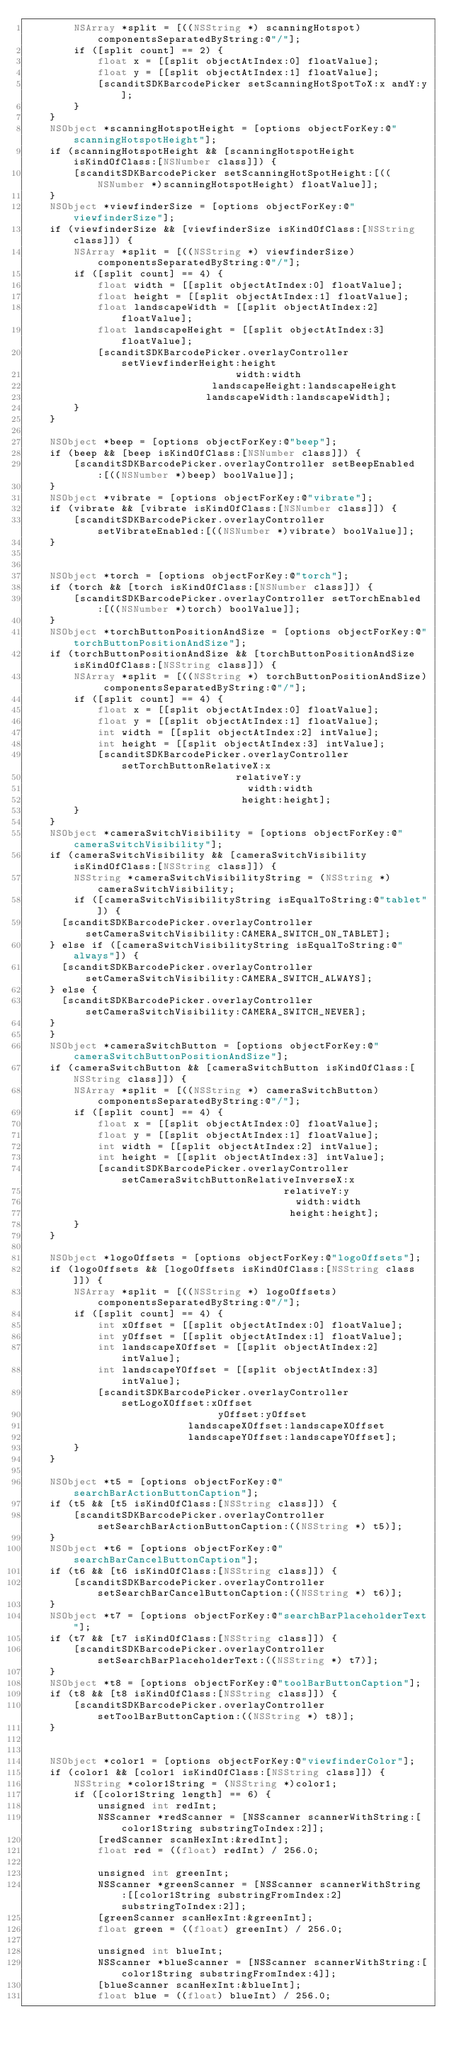Convert code to text. <code><loc_0><loc_0><loc_500><loc_500><_ObjectiveC_>        NSArray *split = [((NSString *) scanningHotspot) componentsSeparatedByString:@"/"];
        if ([split count] == 2) {
            float x = [[split objectAtIndex:0] floatValue];
            float y = [[split objectAtIndex:1] floatValue];
            [scanditSDKBarcodePicker setScanningHotSpotToX:x andY:y];
        }
    }
    NSObject *scanningHotspotHeight = [options objectForKey:@"scanningHotspotHeight"];
    if (scanningHotspotHeight && [scanningHotspotHeight isKindOfClass:[NSNumber class]]) {
        [scanditSDKBarcodePicker setScanningHotSpotHeight:[((NSNumber *)scanningHotspotHeight) floatValue]];
    }
    NSObject *viewfinderSize = [options objectForKey:@"viewfinderSize"];
    if (viewfinderSize && [viewfinderSize isKindOfClass:[NSString class]]) {
        NSArray *split = [((NSString *) viewfinderSize) componentsSeparatedByString:@"/"];
        if ([split count] == 4) {
            float width = [[split objectAtIndex:0] floatValue];
            float height = [[split objectAtIndex:1] floatValue];
            float landscapeWidth = [[split objectAtIndex:2] floatValue];
            float landscapeHeight = [[split objectAtIndex:3] floatValue];
            [scanditSDKBarcodePicker.overlayController setViewfinderHeight:height
																	 width:width
														   landscapeHeight:landscapeHeight
															landscapeWidth:landscapeWidth];
        }
    }
    
    NSObject *beep = [options objectForKey:@"beep"];
    if (beep && [beep isKindOfClass:[NSNumber class]]) {
        [scanditSDKBarcodePicker.overlayController setBeepEnabled:[((NSNumber *)beep) boolValue]];
    }
    NSObject *vibrate = [options objectForKey:@"vibrate"];
    if (vibrate && [vibrate isKindOfClass:[NSNumber class]]) {
        [scanditSDKBarcodePicker.overlayController setVibrateEnabled:[((NSNumber *)vibrate) boolValue]];
    }
	
    
    NSObject *torch = [options objectForKey:@"torch"];
    if (torch && [torch isKindOfClass:[NSNumber class]]) {
        [scanditSDKBarcodePicker.overlayController setTorchEnabled:[((NSNumber *)torch) boolValue]];
    }
    NSObject *torchButtonPositionAndSize = [options objectForKey:@"torchButtonPositionAndSize"];
    if (torchButtonPositionAndSize && [torchButtonPositionAndSize isKindOfClass:[NSString class]]) {
        NSArray *split = [((NSString *) torchButtonPositionAndSize) componentsSeparatedByString:@"/"];
        if ([split count] == 4) {
            float x = [[split objectAtIndex:0] floatValue];
            float y = [[split objectAtIndex:1] floatValue];
            int width = [[split objectAtIndex:2] intValue];
            int height = [[split objectAtIndex:3] intValue];
            [scanditSDKBarcodePicker.overlayController setTorchButtonRelativeX:x
																	 relativeY:y
																		 width:width
																		height:height];
        }
    }
    NSObject *cameraSwitchVisibility = [options objectForKey:@"cameraSwitchVisibility"];
    if (cameraSwitchVisibility && [cameraSwitchVisibility isKindOfClass:[NSString class]]) {
        NSString *cameraSwitchVisibilityString = (NSString *)cameraSwitchVisibility;
        if ([cameraSwitchVisibilityString isEqualToString:@"tablet"]) {
			[scanditSDKBarcodePicker.overlayController setCameraSwitchVisibility:CAMERA_SWITCH_ON_TABLET];
		} else if ([cameraSwitchVisibilityString isEqualToString:@"always"]) {
			[scanditSDKBarcodePicker.overlayController setCameraSwitchVisibility:CAMERA_SWITCH_ALWAYS];
		} else {
			[scanditSDKBarcodePicker.overlayController setCameraSwitchVisibility:CAMERA_SWITCH_NEVER];
		}
    }
    NSObject *cameraSwitchButton = [options objectForKey:@"cameraSwitchButtonPositionAndSize"];
    if (cameraSwitchButton && [cameraSwitchButton isKindOfClass:[NSString class]]) {
        NSArray *split = [((NSString *) cameraSwitchButton) componentsSeparatedByString:@"/"];
        if ([split count] == 4) {
            float x = [[split objectAtIndex:0] floatValue];
            float y = [[split objectAtIndex:1] floatValue];
            int width = [[split objectAtIndex:2] intValue];
            int height = [[split objectAtIndex:3] intValue];
            [scanditSDKBarcodePicker.overlayController setCameraSwitchButtonRelativeInverseX:x
																				   relativeY:y
																					   width:width
																					  height:height];
        }
    }
	
    NSObject *logoOffsets = [options objectForKey:@"logoOffsets"];
    if (logoOffsets && [logoOffsets isKindOfClass:[NSString class]]) {
        NSArray *split = [((NSString *) logoOffsets) componentsSeparatedByString:@"/"];
        if ([split count] == 4) {
            int xOffset = [[split objectAtIndex:0] floatValue];
            int yOffset = [[split objectAtIndex:1] floatValue];
            int landscapeXOffset = [[split objectAtIndex:2] intValue];
            int landscapeYOffset = [[split objectAtIndex:3] intValue];
            [scanditSDKBarcodePicker.overlayController setLogoXOffset:xOffset
															  yOffset:yOffset
													 landscapeXOffset:landscapeXOffset
													 landscapeYOffset:landscapeYOffset];
        }
    }
	
    NSObject *t5 = [options objectForKey:@"searchBarActionButtonCaption"];
    if (t5 && [t5 isKindOfClass:[NSString class]]) {
        [scanditSDKBarcodePicker.overlayController setSearchBarActionButtonCaption:((NSString *) t5)];
    }
    NSObject *t6 = [options objectForKey:@"searchBarCancelButtonCaption"];
    if (t6 && [t6 isKindOfClass:[NSString class]]) {
        [scanditSDKBarcodePicker.overlayController setSearchBarCancelButtonCaption:((NSString *) t6)];
    }
    NSObject *t7 = [options objectForKey:@"searchBarPlaceholderText"];
    if (t7 && [t7 isKindOfClass:[NSString class]]) {
        [scanditSDKBarcodePicker.overlayController setSearchBarPlaceholderText:((NSString *) t7)];
    }
    NSObject *t8 = [options objectForKey:@"toolBarButtonCaption"];
    if (t8 && [t8 isKindOfClass:[NSString class]]) {
        [scanditSDKBarcodePicker.overlayController setToolBarButtonCaption:((NSString *) t8)];
    }
    
    
    NSObject *color1 = [options objectForKey:@"viewfinderColor"];
    if (color1 && [color1 isKindOfClass:[NSString class]]) {
        NSString *color1String = (NSString *)color1;
        if ([color1String length] == 6) {
            unsigned int redInt;
            NSScanner *redScanner = [NSScanner scannerWithString:[color1String substringToIndex:2]];
            [redScanner scanHexInt:&redInt];
            float red = ((float) redInt) / 256.0;
            
            unsigned int greenInt;
            NSScanner *greenScanner = [NSScanner scannerWithString:[[color1String substringFromIndex:2] substringToIndex:2]];
            [greenScanner scanHexInt:&greenInt];
            float green = ((float) greenInt) / 256.0;
            
            unsigned int blueInt;
            NSScanner *blueScanner = [NSScanner scannerWithString:[color1String substringFromIndex:4]];
            [blueScanner scanHexInt:&blueInt];
            float blue = ((float) blueInt) / 256.0;
            </code> 